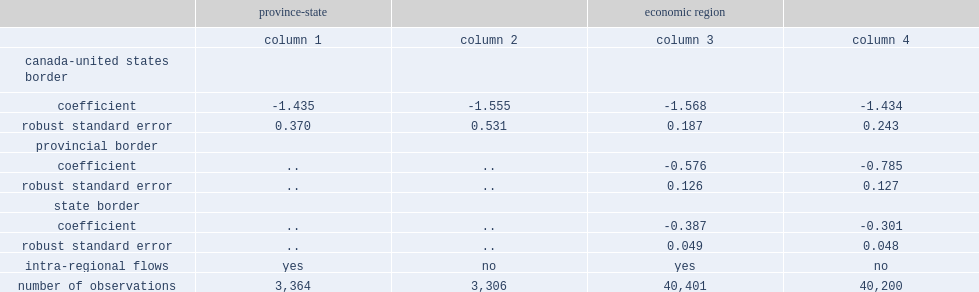What is the canada-united states border effect with intraregional flows? -1.568. What is the canada-united states border effect without intraregional flows? -1.434. What wsa the border effect estimates with accounting for internal flows? -1.435. What wsa the border effect estimates without accounting for internal flows? -1.555. What is the effect of the economic region regressions are able to simultaneously measure provincial border effects when internal flows are included? -0.576. What is the effect of the economic region regressions are able to simultaneously measure state border effects when internal flows are included? -0.387. 